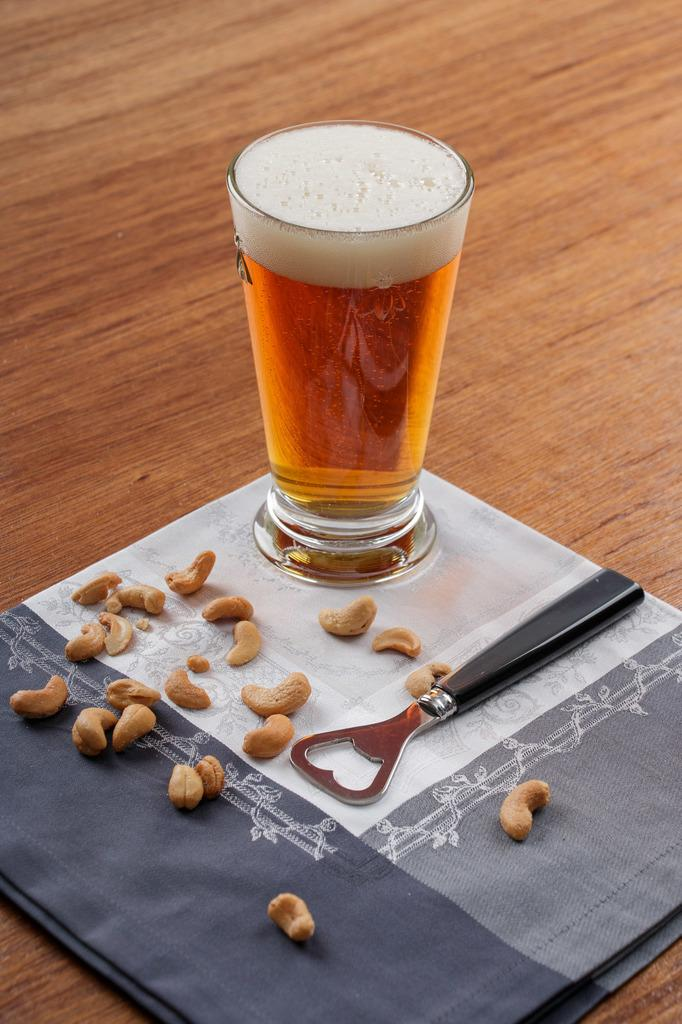What is in the glass that is visible in the image? There is a drink in the glass in the image. What other items can be seen in the image besides the glass? There is a cloth, a bottle opener, and cashews visible in the image. What might be used for opening bottles in the image? A bottle opener is present in the image for opening bottles. What type of food is visible in the image? Cashews are present in the image as a type of food. What color is the tail of the animal in the image? There is no animal with a tail present in the image. How does the wind affect the objects on the platform in the image? There is no wind present in the image, so its effect on the objects cannot be determined. 